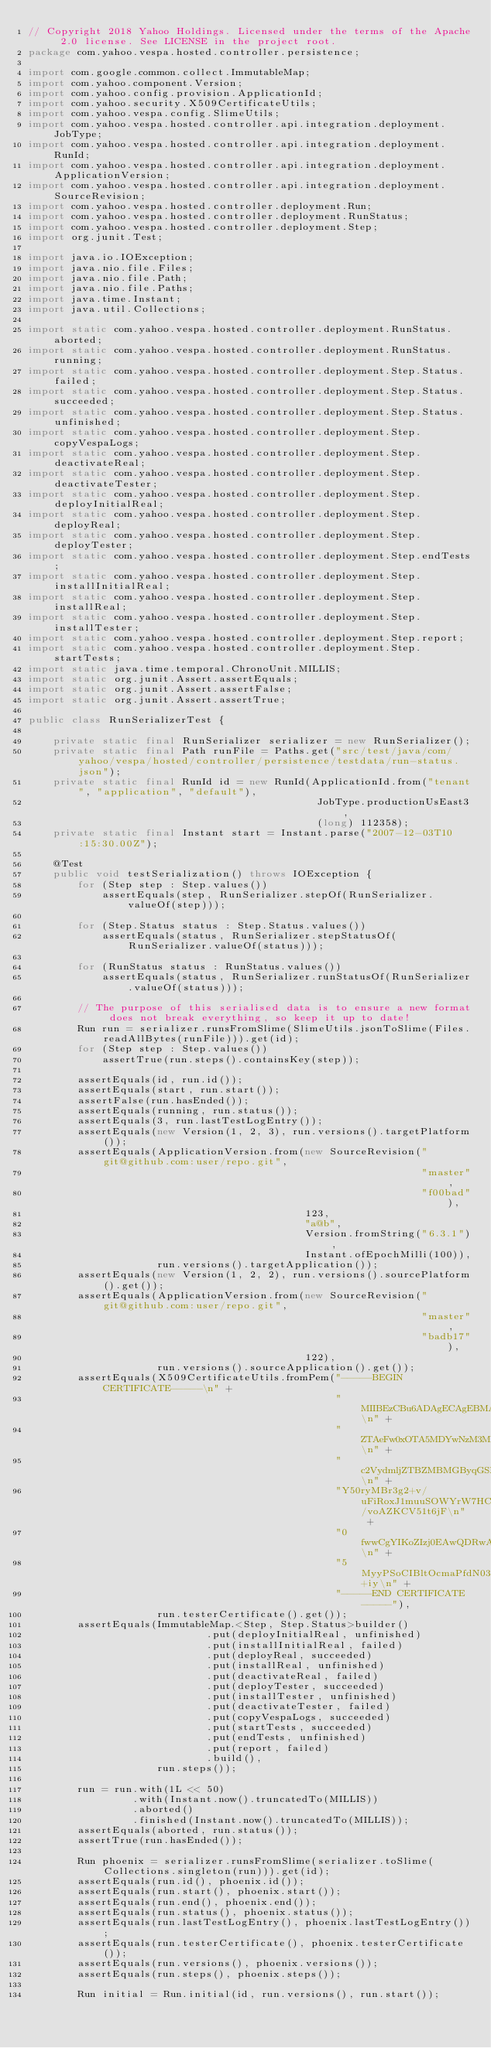Convert code to text. <code><loc_0><loc_0><loc_500><loc_500><_Java_>// Copyright 2018 Yahoo Holdings. Licensed under the terms of the Apache 2.0 license. See LICENSE in the project root.
package com.yahoo.vespa.hosted.controller.persistence;

import com.google.common.collect.ImmutableMap;
import com.yahoo.component.Version;
import com.yahoo.config.provision.ApplicationId;
import com.yahoo.security.X509CertificateUtils;
import com.yahoo.vespa.config.SlimeUtils;
import com.yahoo.vespa.hosted.controller.api.integration.deployment.JobType;
import com.yahoo.vespa.hosted.controller.api.integration.deployment.RunId;
import com.yahoo.vespa.hosted.controller.api.integration.deployment.ApplicationVersion;
import com.yahoo.vespa.hosted.controller.api.integration.deployment.SourceRevision;
import com.yahoo.vespa.hosted.controller.deployment.Run;
import com.yahoo.vespa.hosted.controller.deployment.RunStatus;
import com.yahoo.vespa.hosted.controller.deployment.Step;
import org.junit.Test;

import java.io.IOException;
import java.nio.file.Files;
import java.nio.file.Path;
import java.nio.file.Paths;
import java.time.Instant;
import java.util.Collections;

import static com.yahoo.vespa.hosted.controller.deployment.RunStatus.aborted;
import static com.yahoo.vespa.hosted.controller.deployment.RunStatus.running;
import static com.yahoo.vespa.hosted.controller.deployment.Step.Status.failed;
import static com.yahoo.vespa.hosted.controller.deployment.Step.Status.succeeded;
import static com.yahoo.vespa.hosted.controller.deployment.Step.Status.unfinished;
import static com.yahoo.vespa.hosted.controller.deployment.Step.copyVespaLogs;
import static com.yahoo.vespa.hosted.controller.deployment.Step.deactivateReal;
import static com.yahoo.vespa.hosted.controller.deployment.Step.deactivateTester;
import static com.yahoo.vespa.hosted.controller.deployment.Step.deployInitialReal;
import static com.yahoo.vespa.hosted.controller.deployment.Step.deployReal;
import static com.yahoo.vespa.hosted.controller.deployment.Step.deployTester;
import static com.yahoo.vespa.hosted.controller.deployment.Step.endTests;
import static com.yahoo.vespa.hosted.controller.deployment.Step.installInitialReal;
import static com.yahoo.vespa.hosted.controller.deployment.Step.installReal;
import static com.yahoo.vespa.hosted.controller.deployment.Step.installTester;
import static com.yahoo.vespa.hosted.controller.deployment.Step.report;
import static com.yahoo.vespa.hosted.controller.deployment.Step.startTests;
import static java.time.temporal.ChronoUnit.MILLIS;
import static org.junit.Assert.assertEquals;
import static org.junit.Assert.assertFalse;
import static org.junit.Assert.assertTrue;

public class RunSerializerTest {

    private static final RunSerializer serializer = new RunSerializer();
    private static final Path runFile = Paths.get("src/test/java/com/yahoo/vespa/hosted/controller/persistence/testdata/run-status.json");
    private static final RunId id = new RunId(ApplicationId.from("tenant", "application", "default"),
                                               JobType.productionUsEast3,
                                               (long) 112358);
    private static final Instant start = Instant.parse("2007-12-03T10:15:30.00Z");

    @Test
    public void testSerialization() throws IOException {
        for (Step step : Step.values())
            assertEquals(step, RunSerializer.stepOf(RunSerializer.valueOf(step)));

        for (Step.Status status : Step.Status.values())
            assertEquals(status, RunSerializer.stepStatusOf(RunSerializer.valueOf(status)));

        for (RunStatus status : RunStatus.values())
            assertEquals(status, RunSerializer.runStatusOf(RunSerializer.valueOf(status)));

        // The purpose of this serialised data is to ensure a new format does not break everything, so keep it up to date!
        Run run = serializer.runsFromSlime(SlimeUtils.jsonToSlime(Files.readAllBytes(runFile))).get(id);
        for (Step step : Step.values())
            assertTrue(run.steps().containsKey(step));

        assertEquals(id, run.id());
        assertEquals(start, run.start());
        assertFalse(run.hasEnded());
        assertEquals(running, run.status());
        assertEquals(3, run.lastTestLogEntry());
        assertEquals(new Version(1, 2, 3), run.versions().targetPlatform());
        assertEquals(ApplicationVersion.from(new SourceRevision("git@github.com:user/repo.git",
                                                                "master",
                                                                "f00bad"),
                                             123,
                                             "a@b",
                                             Version.fromString("6.3.1"),
                                             Instant.ofEpochMilli(100)),
                     run.versions().targetApplication());
        assertEquals(new Version(1, 2, 2), run.versions().sourcePlatform().get());
        assertEquals(ApplicationVersion.from(new SourceRevision("git@github.com:user/repo.git",
                                                                "master",
                                                                "badb17"),
                                             122),
                     run.versions().sourceApplication().get());
        assertEquals(X509CertificateUtils.fromPem("-----BEGIN CERTIFICATE-----\n" +
                                                  "MIIBEzCBu6ADAgECAgEBMAoGCCqGSM49BAMEMBQxEjAQBgNVBAMTCW15c2Vydmlj\n" +
                                                  "ZTAeFw0xOTA5MDYwNzM3MDZaFw0xOTA5MDcwNzM3MDZaMBQxEjAQBgNVBAMTCW15\n" +
                                                  "c2VydmljZTBZMBMGByqGSM49AgEGCCqGSM49AwEHA0IABM0JhD8fV2DlAkjQOGX3\n" +
                                                  "Y50ryMBr3g2+v/uFiRoxJ1muuSOWYrW7HCQIGuzc04fa0QwtaX/voAZKCV51t6jF\n" +
                                                  "0fwwCgYIKoZIzj0EAwQDRwAwRAIgVbQ3Co1H4X0gmRrtXSyTU0HgBQu9PXHMmX20\n" +
                                                  "5MyyPSoCIBltOcmaPfdN03L3zqbqZ6PgUBWsvAHgiBzL3hrtJ+iy\n" +
                                                  "-----END CERTIFICATE-----"),
                     run.testerCertificate().get());
        assertEquals(ImmutableMap.<Step, Step.Status>builder()
                             .put(deployInitialReal, unfinished)
                             .put(installInitialReal, failed)
                             .put(deployReal, succeeded)
                             .put(installReal, unfinished)
                             .put(deactivateReal, failed)
                             .put(deployTester, succeeded)
                             .put(installTester, unfinished)
                             .put(deactivateTester, failed)
                             .put(copyVespaLogs, succeeded)
                             .put(startTests, succeeded)
                             .put(endTests, unfinished)
                             .put(report, failed)
                             .build(),
                     run.steps());

        run = run.with(1L << 50)
                 .with(Instant.now().truncatedTo(MILLIS))
                 .aborted()
                 .finished(Instant.now().truncatedTo(MILLIS));
        assertEquals(aborted, run.status());
        assertTrue(run.hasEnded());

        Run phoenix = serializer.runsFromSlime(serializer.toSlime(Collections.singleton(run))).get(id);
        assertEquals(run.id(), phoenix.id());
        assertEquals(run.start(), phoenix.start());
        assertEquals(run.end(), phoenix.end());
        assertEquals(run.status(), phoenix.status());
        assertEquals(run.lastTestLogEntry(), phoenix.lastTestLogEntry());
        assertEquals(run.testerCertificate(), phoenix.testerCertificate());
        assertEquals(run.versions(), phoenix.versions());
        assertEquals(run.steps(), phoenix.steps());

        Run initial = Run.initial(id, run.versions(), run.start());</code> 